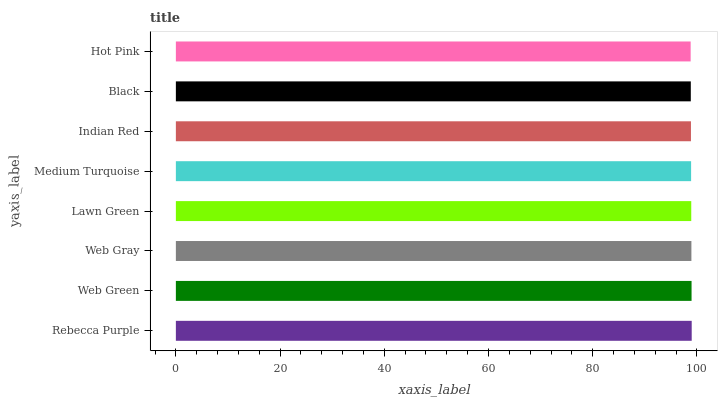Is Hot Pink the minimum?
Answer yes or no. Yes. Is Rebecca Purple the maximum?
Answer yes or no. Yes. Is Web Green the minimum?
Answer yes or no. No. Is Web Green the maximum?
Answer yes or no. No. Is Rebecca Purple greater than Web Green?
Answer yes or no. Yes. Is Web Green less than Rebecca Purple?
Answer yes or no. Yes. Is Web Green greater than Rebecca Purple?
Answer yes or no. No. Is Rebecca Purple less than Web Green?
Answer yes or no. No. Is Lawn Green the high median?
Answer yes or no. Yes. Is Medium Turquoise the low median?
Answer yes or no. Yes. Is Indian Red the high median?
Answer yes or no. No. Is Web Gray the low median?
Answer yes or no. No. 